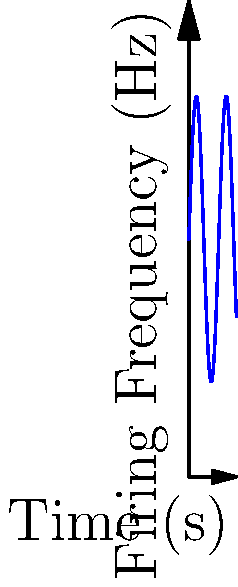Given the graph of neuron firing frequency over time, calculate the instantaneous rate of change in neural activity at $t = \frac{\pi}{2}$ seconds. Assume the function describing this activity is $f(t) = 50 + 30\sin(t)$, where $f(t)$ is the firing frequency in Hz and $t$ is time in seconds. To find the instantaneous rate of change, we need to calculate the derivative of the function at the given point. Let's approach this step-by-step:

1) The given function is $f(t) = 50 + 30\sin(t)$

2) To find the rate of change, we need to differentiate this function:
   $f'(t) = 30\cos(t)$

3) We're asked to find the rate of change at $t = \frac{\pi}{2}$

4) Let's substitute this value into our derivative:
   $f'(\frac{\pi}{2}) = 30\cos(\frac{\pi}{2})$

5) Recall that $\cos(\frac{\pi}{2}) = 0$

6) Therefore:
   $f'(\frac{\pi}{2}) = 30 \cdot 0 = 0$

The instantaneous rate of change at $t = \frac{\pi}{2}$ seconds is 0 Hz/s. This means that at this exact moment, the firing frequency is neither increasing nor decreasing.
Answer: 0 Hz/s 